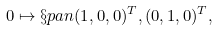Convert formula to latex. <formula><loc_0><loc_0><loc_500><loc_500>0 \mapsto \S p a n { ( 1 , 0 , 0 ) ^ { T } , ( 0 , 1 , 0 ) ^ { T } } ,</formula> 